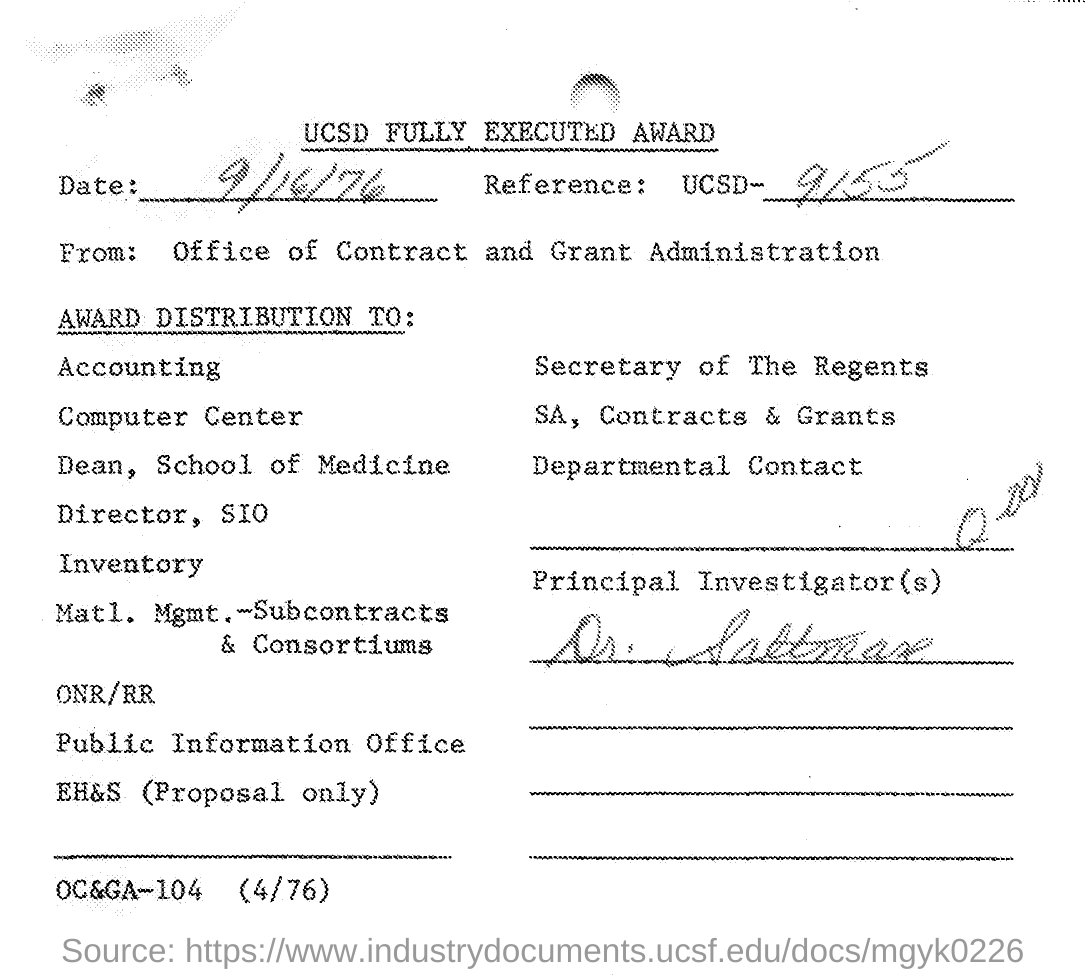What is the reference ucsd number mentioned in the given letter ?
Your answer should be very brief. 9155. What is the name of principal investigator mentioned in the given letter ?
Ensure brevity in your answer.  Dr. Saltman. 